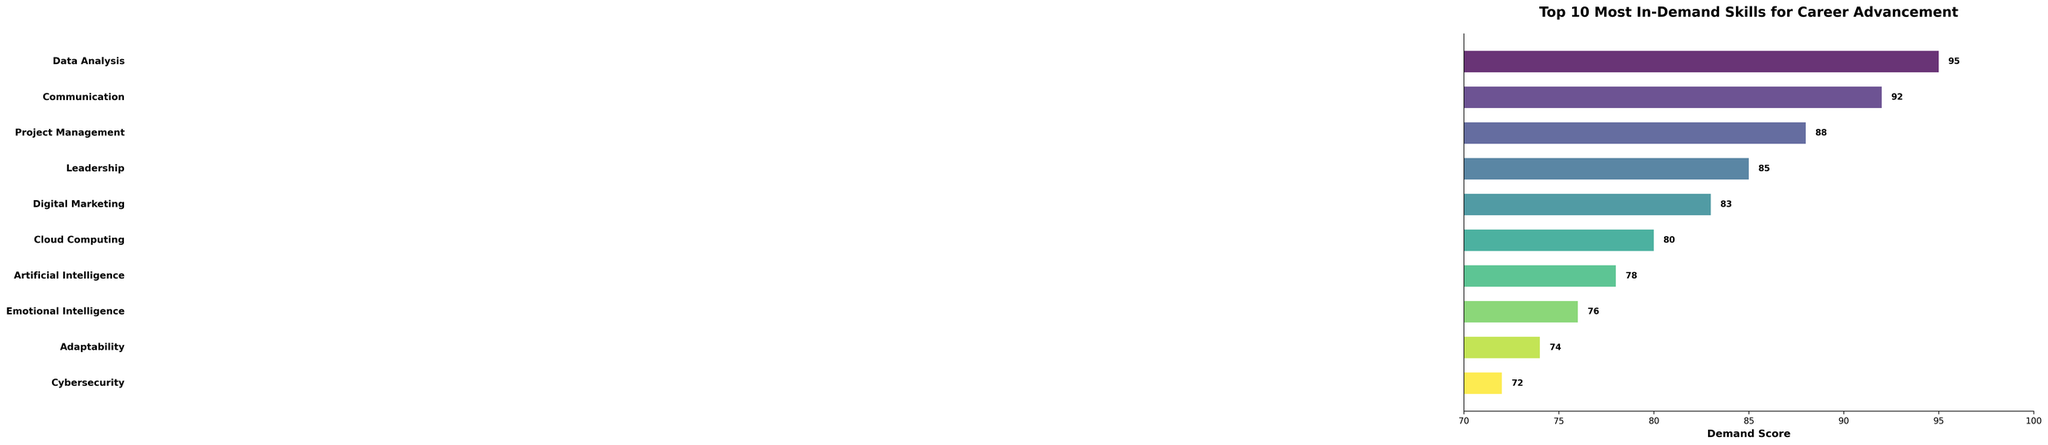What is the most in-demand skill for career advancement? The bar chart lists the skills according to their demand scores. The skill with the highest score is at the top.
Answer: Data Analysis Which skill has a higher demand score, Emotional Intelligence or Adaptability? By comparing the demand scores of Emotional Intelligence (76) and Adaptability (74) from the chart, we can see which is higher.
Answer: Emotional Intelligence What is the total demand score of the top 3 skills combined? Summing the demand scores of the top 3 skills: Data Analysis (95), Communication (92), and Project Management (88). The calculation is 95 + 92 + 88 = 275.
Answer: 275 How many skills have a demand score equal to or greater than 80? By counting the number of skills that have a demand score of 80 or more from the chart. These skills are Data Analysis, Communication, Project Management, Leadership, Digital Marketing, Cloud Computing. That makes 6 skills.
Answer: 6 Which skill has the lowest demand score on the chart? The skill listed at the very bottom of the bar chart represents the skill with the lowest demand score.
Answer: Cybersecurity Is the demand score for Project Management closer to that of Leadership or to Digital Marketing? The demand score for Project Management is 88, for Leadership is 85, and for Digital Marketing is 83. The differences are 3 (88 - 85) and 5 (88 - 83), respectively, making it closer to Leadership.
Answer: Leadership What are the colors used in the bar representing Artificial Intelligence and Cybersecurity? The chart uses a gradient color scheme. The bar for Artificial Intelligence is lighter than the bar for Cybersecurity, which is one of the darkest bars (near the bottom of the gradient).
Answer: Artificial Intelligence: Lighter; Cybersecurity: Darker What is the difference between the demand scores of Data Analysis and Digital Marketing? Subtracting the demand score of Digital Marketing (83) from Data Analysis (95) results in the difference: 95 - 83 = 12.
Answer: 12 What is the average demand score of all the skills? Adding all demand scores: 95 + 92 + 88 + 85 + 83 + 80 + 78 + 76 + 74 + 72 = 823. Dividing by the number of skills (10) gives the average: 823 / 10 = 82.3.
Answer: 82.3 